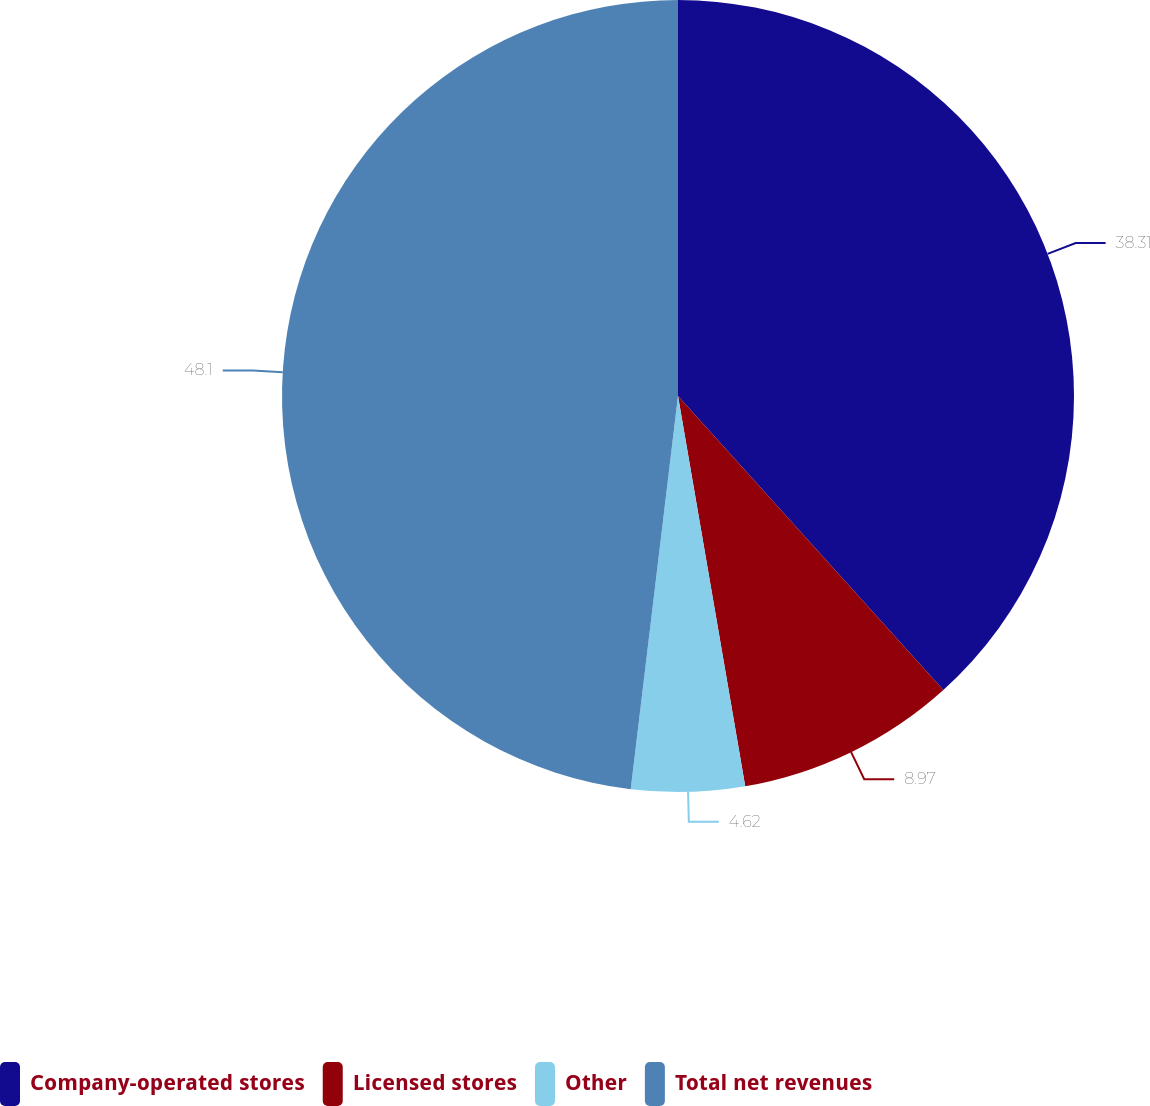<chart> <loc_0><loc_0><loc_500><loc_500><pie_chart><fcel>Company-operated stores<fcel>Licensed stores<fcel>Other<fcel>Total net revenues<nl><fcel>38.31%<fcel>8.97%<fcel>4.62%<fcel>48.09%<nl></chart> 